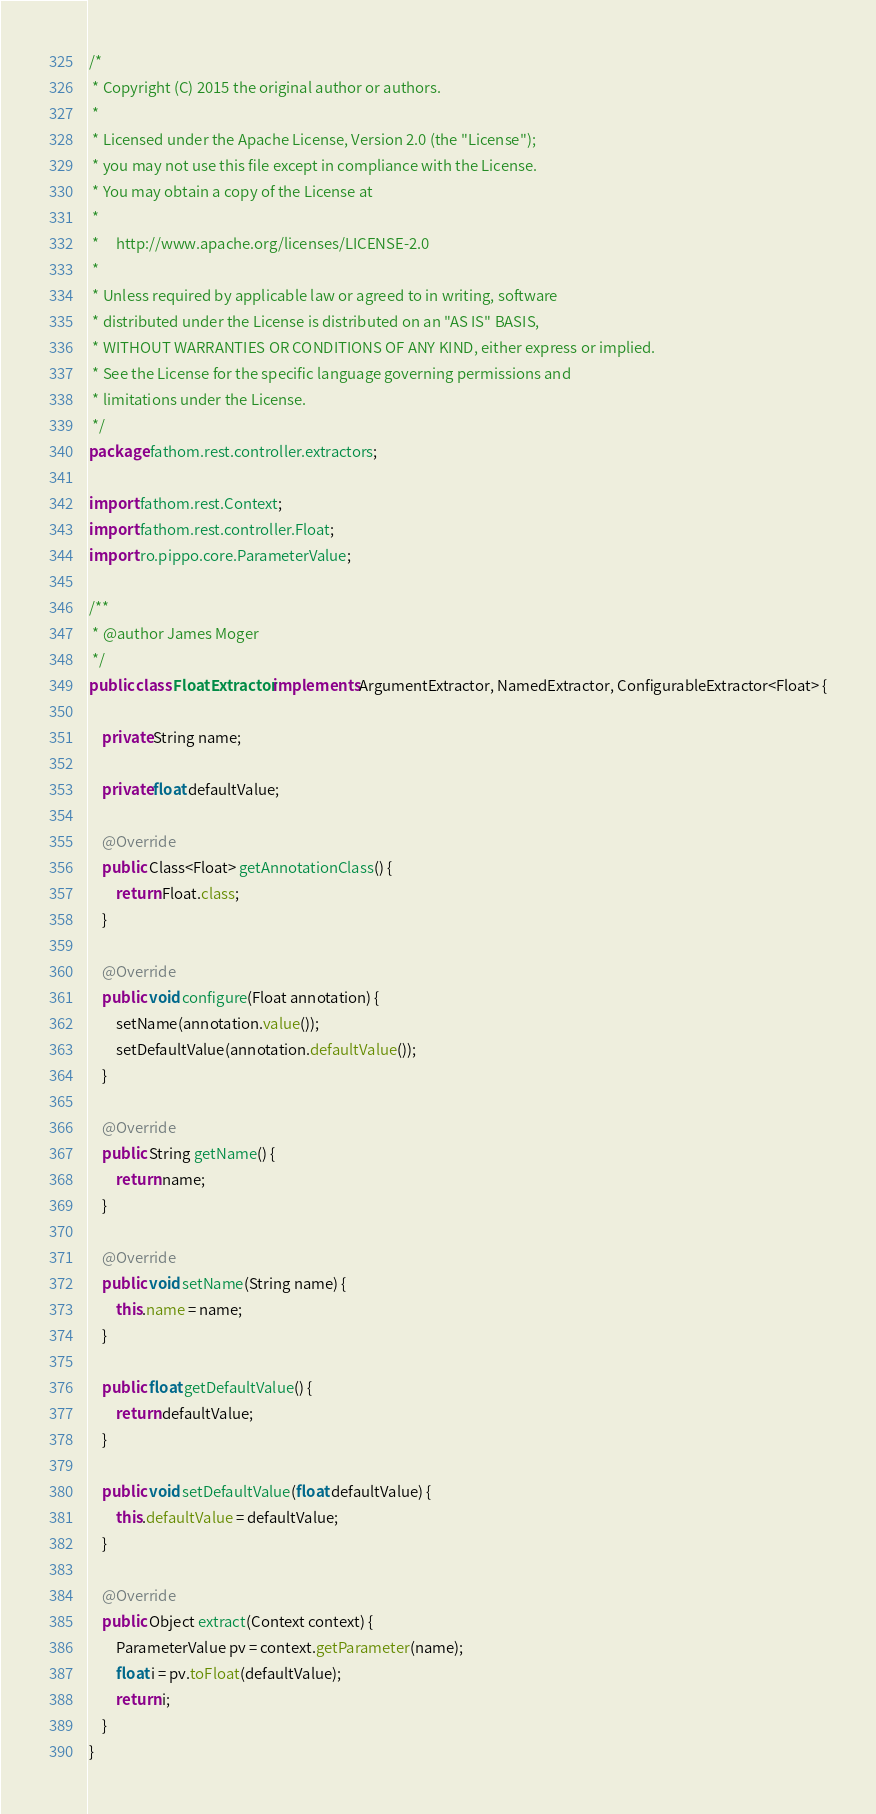<code> <loc_0><loc_0><loc_500><loc_500><_Java_>/*
 * Copyright (C) 2015 the original author or authors.
 *
 * Licensed under the Apache License, Version 2.0 (the "License");
 * you may not use this file except in compliance with the License.
 * You may obtain a copy of the License at
 *
 *     http://www.apache.org/licenses/LICENSE-2.0
 *
 * Unless required by applicable law or agreed to in writing, software
 * distributed under the License is distributed on an "AS IS" BASIS,
 * WITHOUT WARRANTIES OR CONDITIONS OF ANY KIND, either express or implied.
 * See the License for the specific language governing permissions and
 * limitations under the License.
 */
package fathom.rest.controller.extractors;

import fathom.rest.Context;
import fathom.rest.controller.Float;
import ro.pippo.core.ParameterValue;

/**
 * @author James Moger
 */
public class FloatExtractor implements ArgumentExtractor, NamedExtractor, ConfigurableExtractor<Float> {

    private String name;

    private float defaultValue;

    @Override
    public Class<Float> getAnnotationClass() {
        return Float.class;
    }

    @Override
    public void configure(Float annotation) {
        setName(annotation.value());
        setDefaultValue(annotation.defaultValue());
    }

    @Override
    public String getName() {
        return name;
    }

    @Override
    public void setName(String name) {
        this.name = name;
    }

    public float getDefaultValue() {
        return defaultValue;
    }

    public void setDefaultValue(float defaultValue) {
        this.defaultValue = defaultValue;
    }

    @Override
    public Object extract(Context context) {
        ParameterValue pv = context.getParameter(name);
        float i = pv.toFloat(defaultValue);
        return i;
    }
}
</code> 